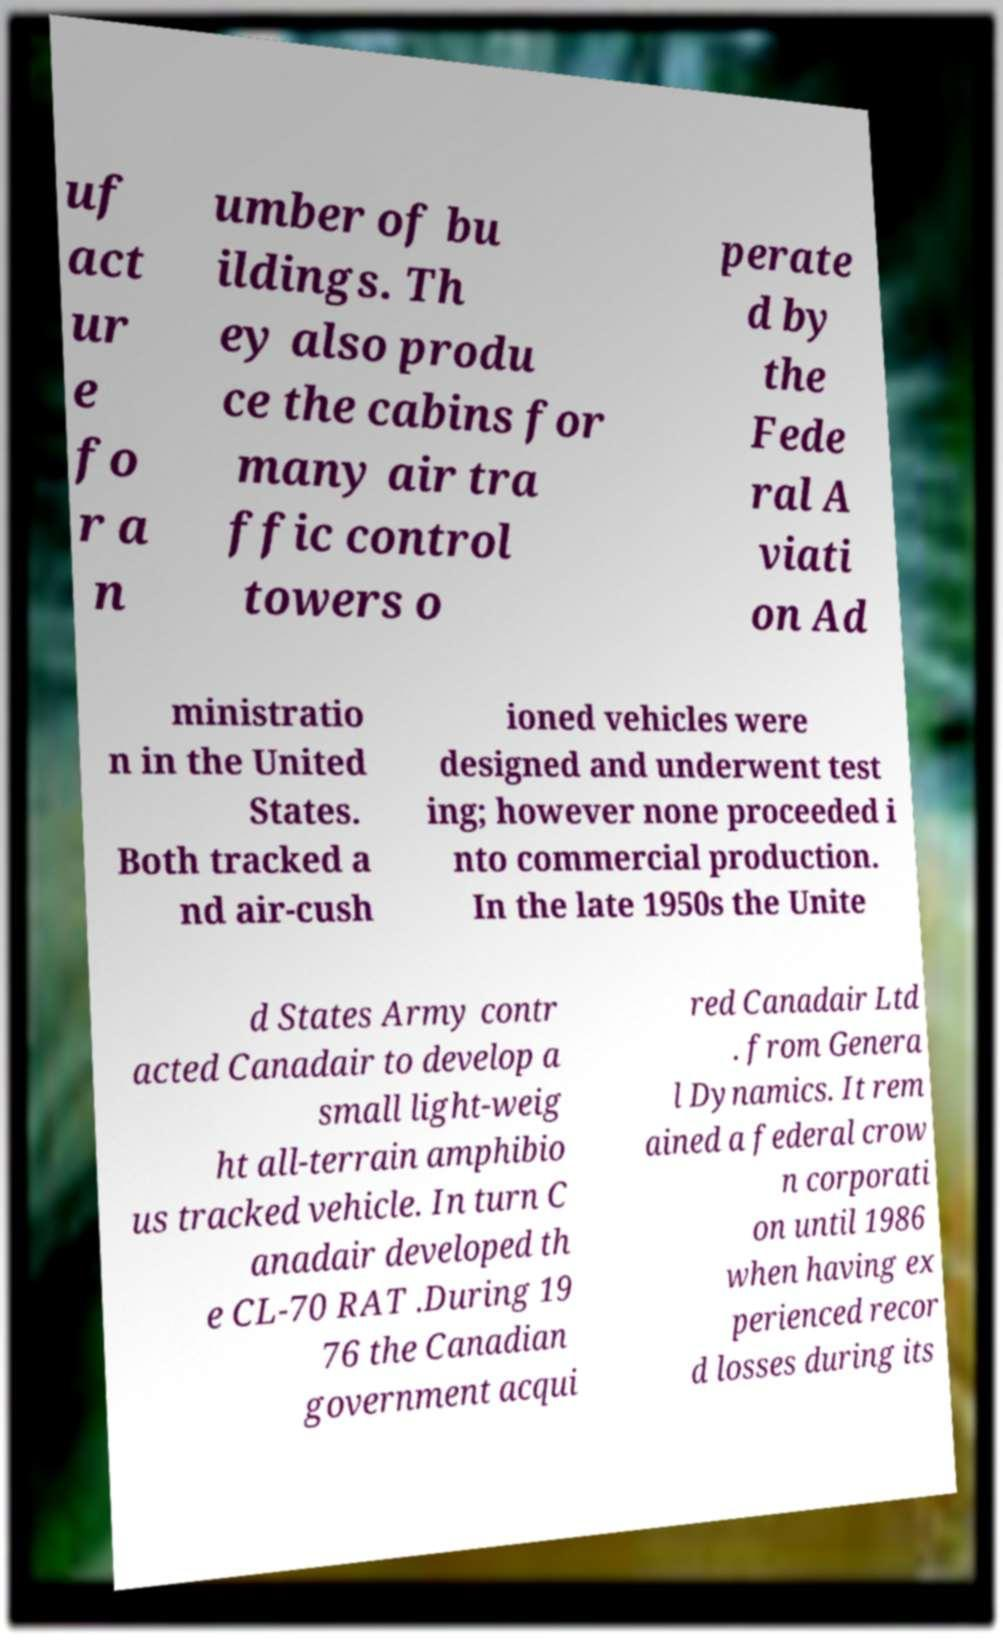Could you extract and type out the text from this image? uf act ur e fo r a n umber of bu ildings. Th ey also produ ce the cabins for many air tra ffic control towers o perate d by the Fede ral A viati on Ad ministratio n in the United States. Both tracked a nd air-cush ioned vehicles were designed and underwent test ing; however none proceeded i nto commercial production. In the late 1950s the Unite d States Army contr acted Canadair to develop a small light-weig ht all-terrain amphibio us tracked vehicle. In turn C anadair developed th e CL-70 RAT .During 19 76 the Canadian government acqui red Canadair Ltd . from Genera l Dynamics. It rem ained a federal crow n corporati on until 1986 when having ex perienced recor d losses during its 